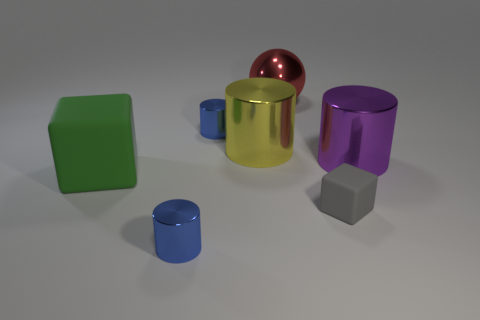Subtract all large yellow metallic cylinders. How many cylinders are left? 3 Subtract all purple cylinders. How many cylinders are left? 3 Add 1 red objects. How many objects exist? 8 Subtract 1 cubes. How many cubes are left? 1 Subtract all green cylinders. How many yellow spheres are left? 0 Subtract all tiny blue rubber cylinders. Subtract all large green matte blocks. How many objects are left? 6 Add 4 small gray matte blocks. How many small gray matte blocks are left? 5 Add 3 tiny gray spheres. How many tiny gray spheres exist? 3 Subtract 0 blue blocks. How many objects are left? 7 Subtract all blocks. How many objects are left? 5 